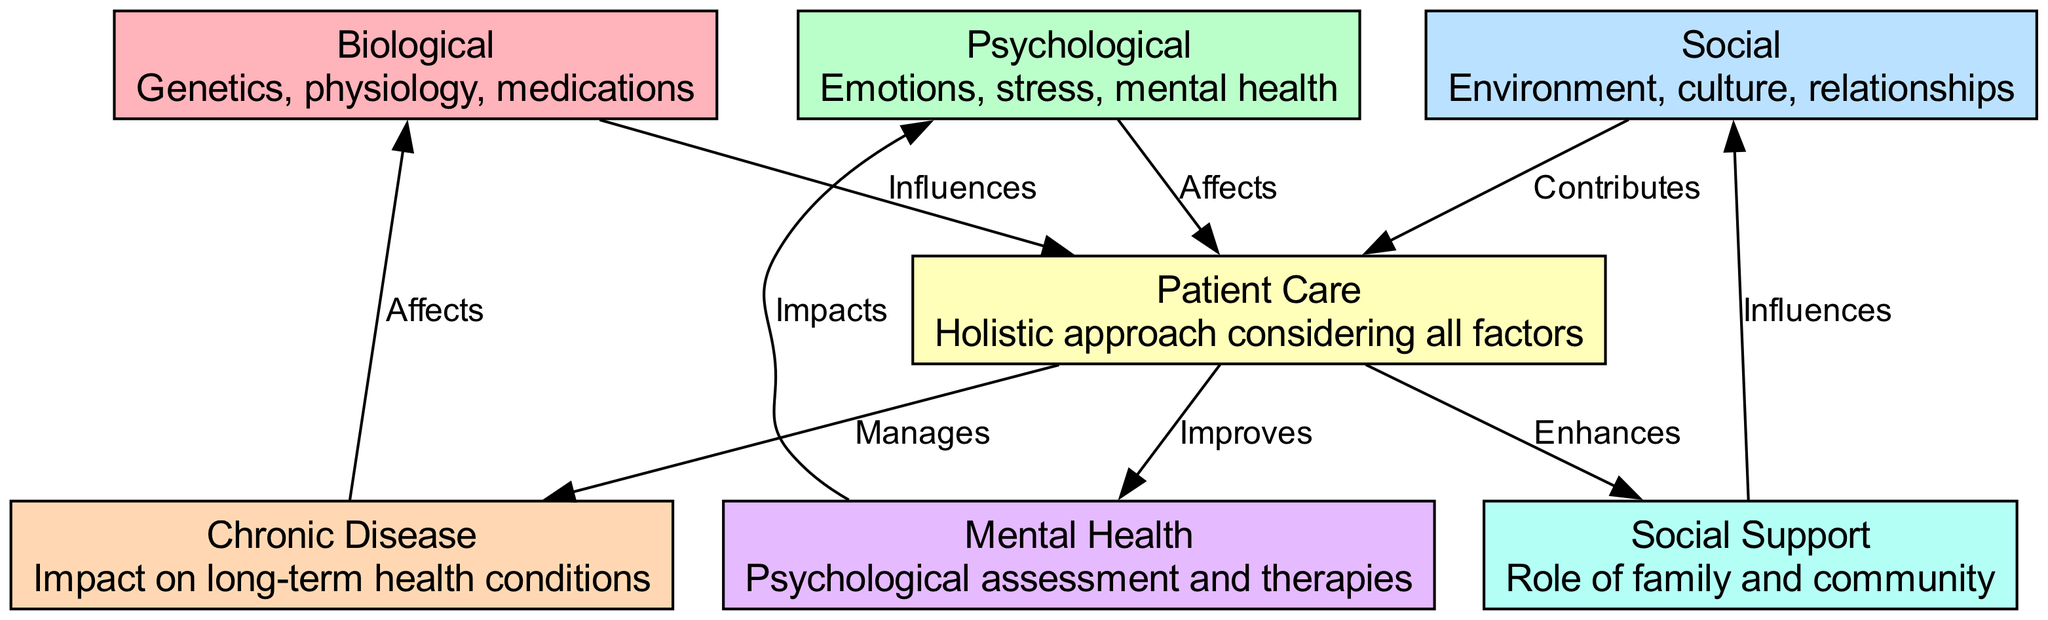What are the three main components of the Biopsychosocial Model? The diagram lists three main components: Biological, Psychological, and Social. These are clearly marked as nodes in the diagram.
Answer: Biological, Psychological, Social How many edges are present in the diagram? By counting the connections (edges) shown between the nodes, we find there are a total of 9 edges in the diagram.
Answer: 9 What does the Biological factor influence in patient care? The edge from the Biological node to the Patient Care node indicates that Biological factors influence patient care.
Answer: Influences Patient Care Which factor contributes to Patient Care? The diagram shows that the Social factor contributes to Patient Care, as indicated by the edge leading from the Social node to the Patient Care node.
Answer: Contributes What is the relationship between Patient Care and Chronic Disease? The edge connecting Patient Care to Chronic Disease shows that Patient Care manages Chronic Disease, meaning it plays a role in handling chronic health conditions.
Answer: Manages How does Mental Health relate to Psychological factors? According to the diagram, the edge from Mental Health to Psychological indicates that Mental Health impacts Psychological factors, showing an influence in that direction.
Answer: Impacts What enhances Patient Care according to the diagram? The diagram illustrates that Social Support enhances Patient Care as shown by the connecting edge from Social Support to Patient Care.
Answer: Enhances What factors are included in the Biological component? The Biological node description mentions Genetics, physiology, and medications as the factors included in this category.
Answer: Genetics, physiology, medications What does the Social factor influence? The edge from Social Support to Social indicates that Social Support influences Social factors, showcasing the impact that social networks and relationships have on the overall social environment.
Answer: Influences 